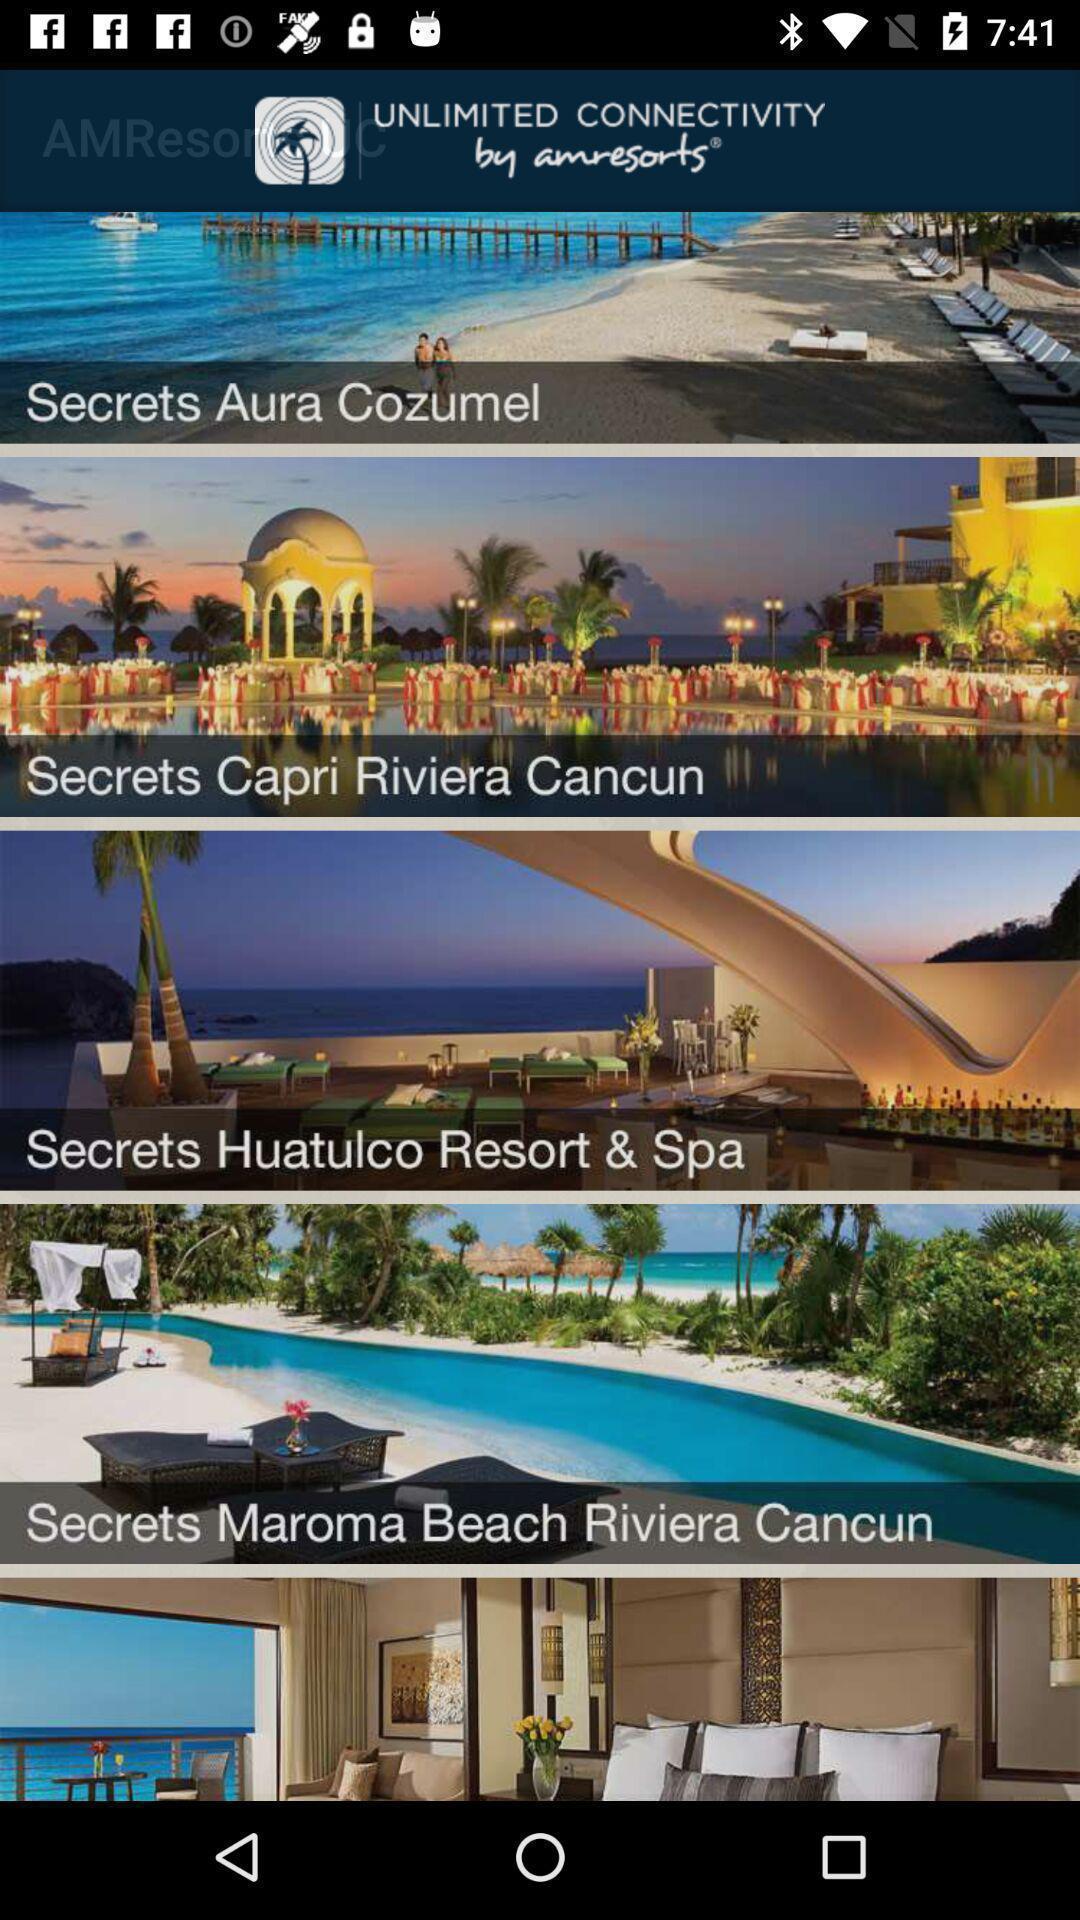Tell me what you see in this picture. Page displaying with list of different resort options. 